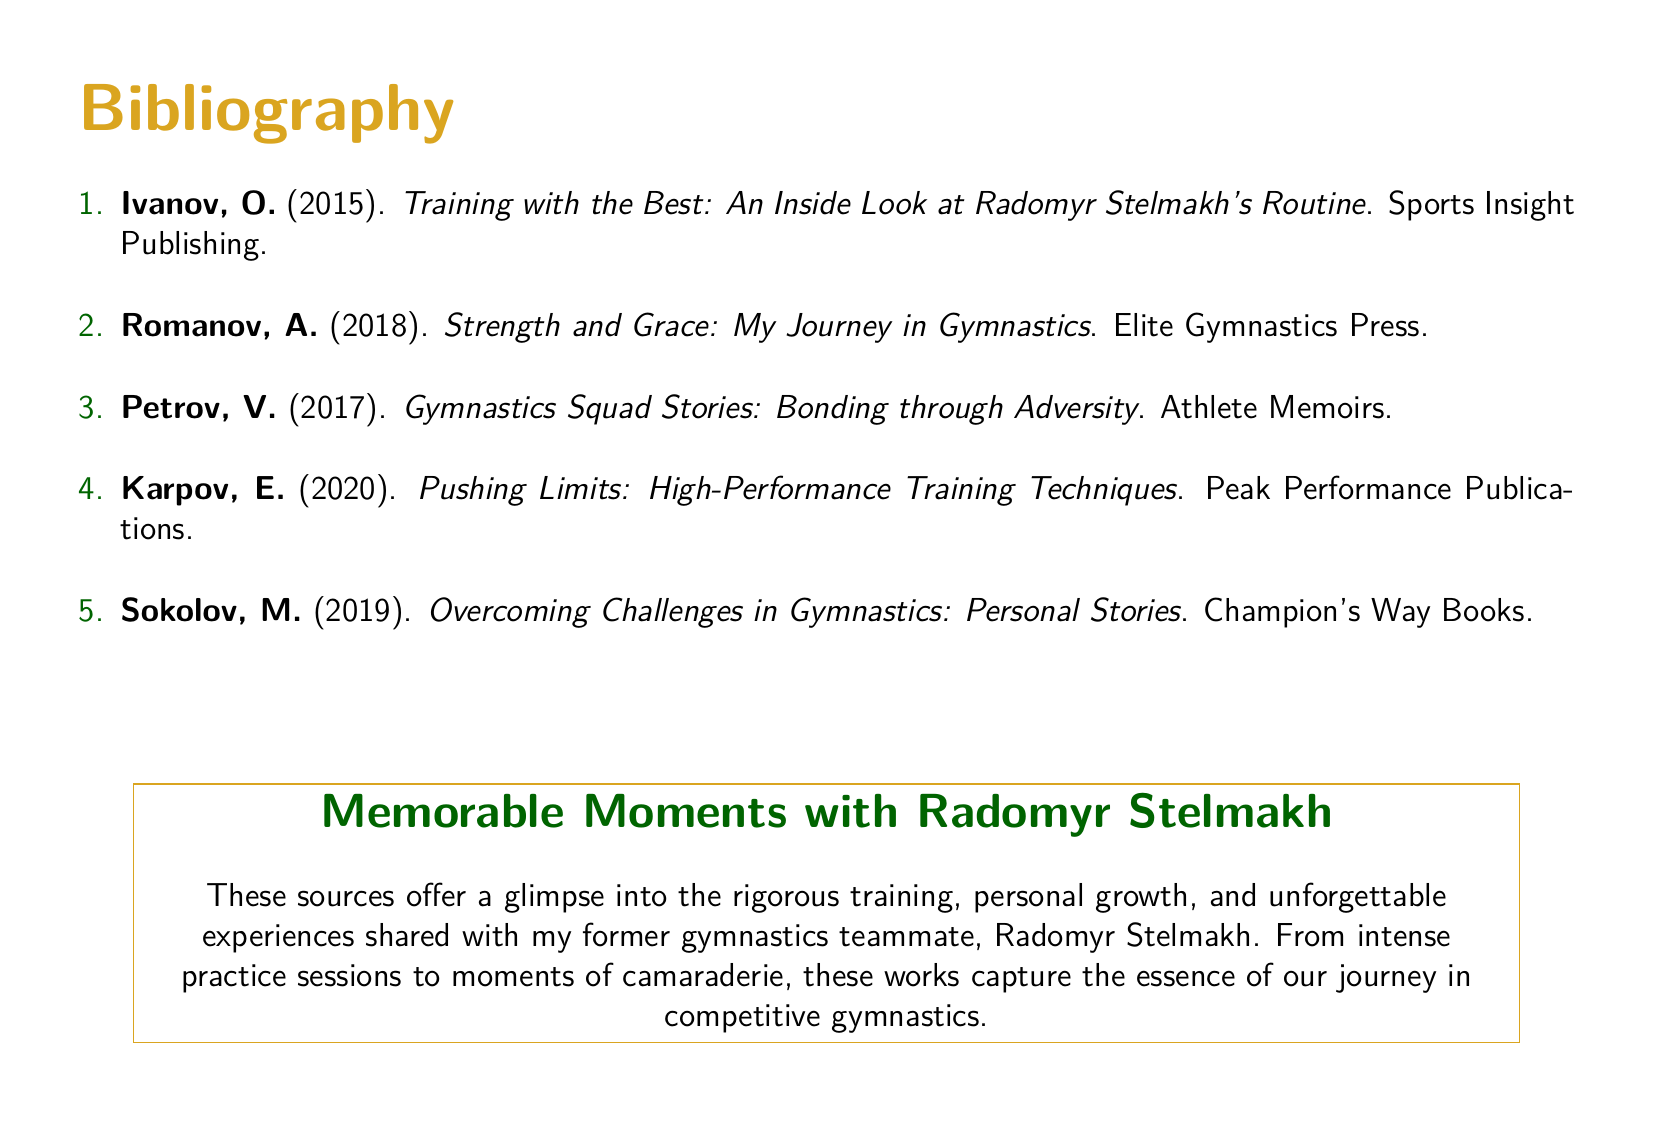What is the title of the first source? The first source in the bibliography lists the title as "Training with the Best: An Inside Look at Radomyr Stelmakh's Routine."
Answer: Training with the Best: An Inside Look at Radomyr Stelmakh's Routine Who is the author of the second source? The second source is authored by A. Romanov.
Answer: A. Romanov In which year was the source "Gymnastics Squad Stories: Bonding through Adversity" published? According to the bibliography, this source was published in 2017.
Answer: 2017 How many sources are listed in the bibliography? The bibliography lists a total of 5 sources.
Answer: 5 Which color is used for the section titles in the document? The section titles are colored gymnast, which is defined by the RGB value (218,165,32).
Answer: gymnast What publishing house released "Overcoming Challenges in Gymnastics: Personal Stories"? This source was published by Champion's Way Books.
Answer: Champion's Way Books Who is the main subject of the memorable moments described in the document? The main subject of the memorable moments is Radomyr Stelmakh.
Answer: Radomyr Stelmakh What is the purpose of the bibliography as mentioned in the document? The bibliography serves to provide a glimpse into the training, growth, and experiences shared with Radomyr Stelmakh.
Answer: To provide a glimpse into training, growth, and experiences 